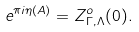<formula> <loc_0><loc_0><loc_500><loc_500>e ^ { \pi i \eta ( A ) } = Z ^ { o } _ { \Gamma , \Lambda } ( 0 ) .</formula> 